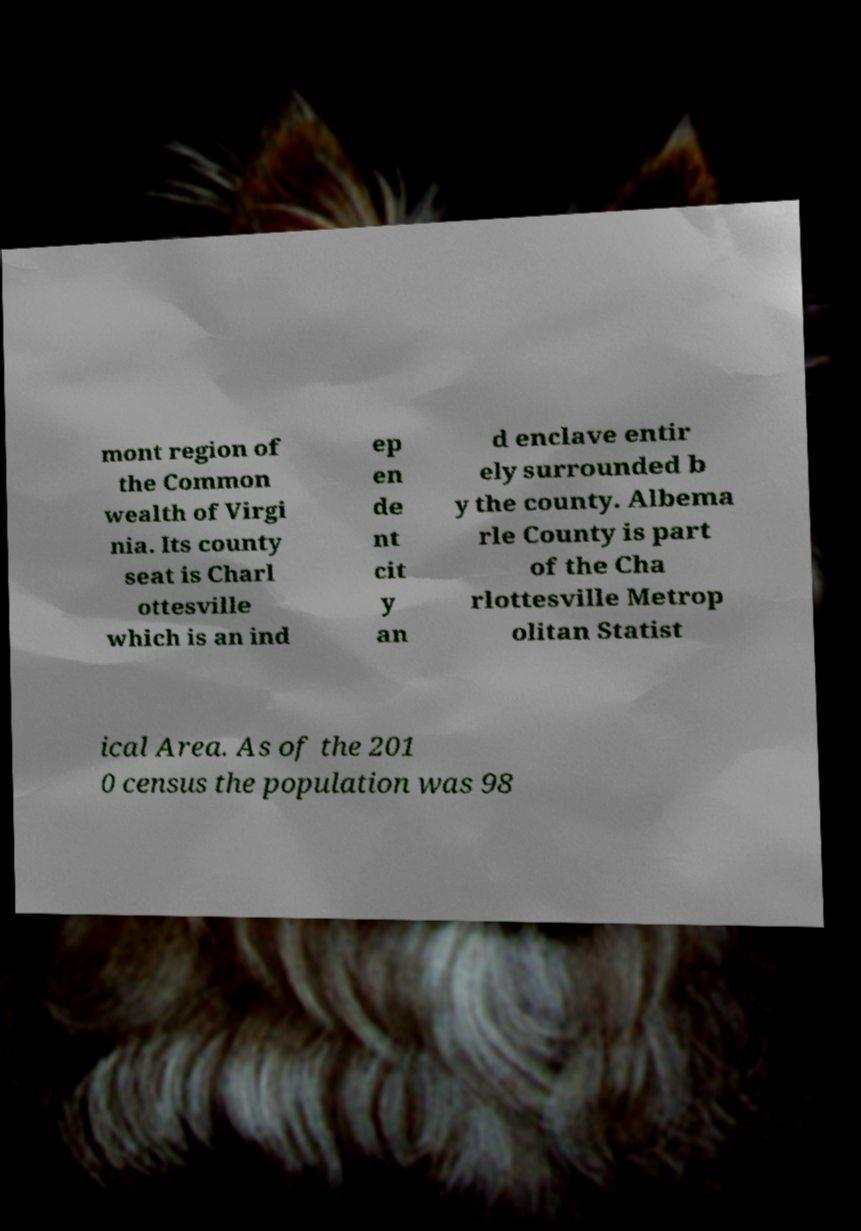Could you assist in decoding the text presented in this image and type it out clearly? mont region of the Common wealth of Virgi nia. Its county seat is Charl ottesville which is an ind ep en de nt cit y an d enclave entir ely surrounded b y the county. Albema rle County is part of the Cha rlottesville Metrop olitan Statist ical Area. As of the 201 0 census the population was 98 